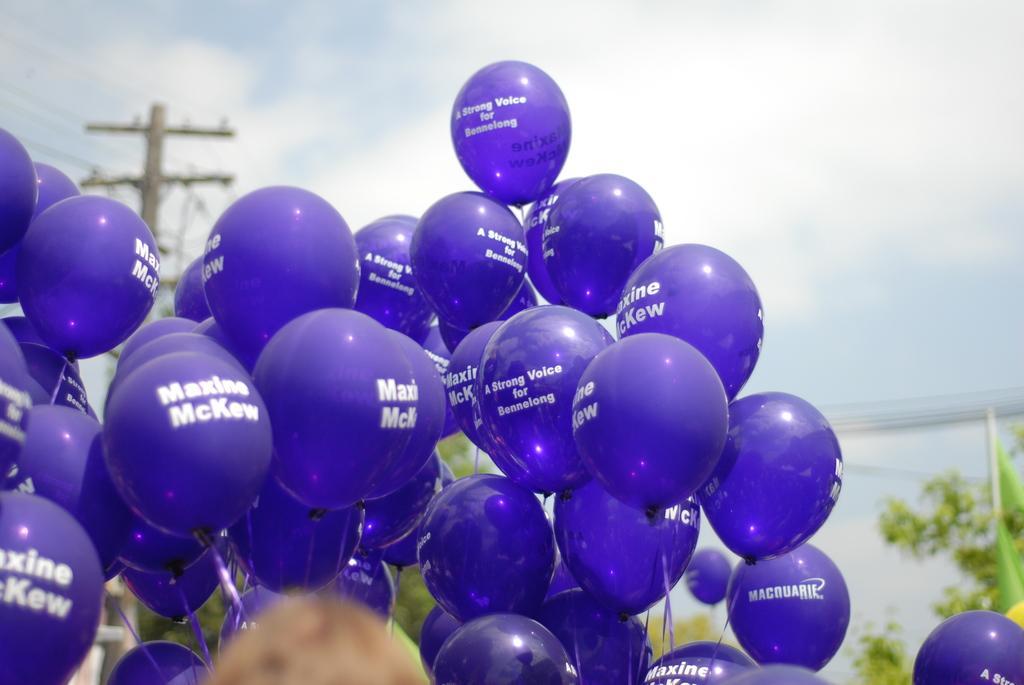In one or two sentences, can you explain what this image depicts? In this image we can see a few balloons with text on them, there are wires connected to an electric pole, there are trees, flag, also we can see the sky, and the background is blurred. 